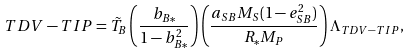<formula> <loc_0><loc_0><loc_500><loc_500>T D V - T I P & = \tilde { T } _ { B } \left ( \frac { b _ { B * } } { 1 - b _ { B * } ^ { 2 } } \right ) \left ( \frac { a _ { S B } M _ { S } ( 1 - e _ { S B } ^ { 2 } ) } { R _ { * } M _ { P } } \right ) \Lambda _ { T D V - T I P } ,</formula> 